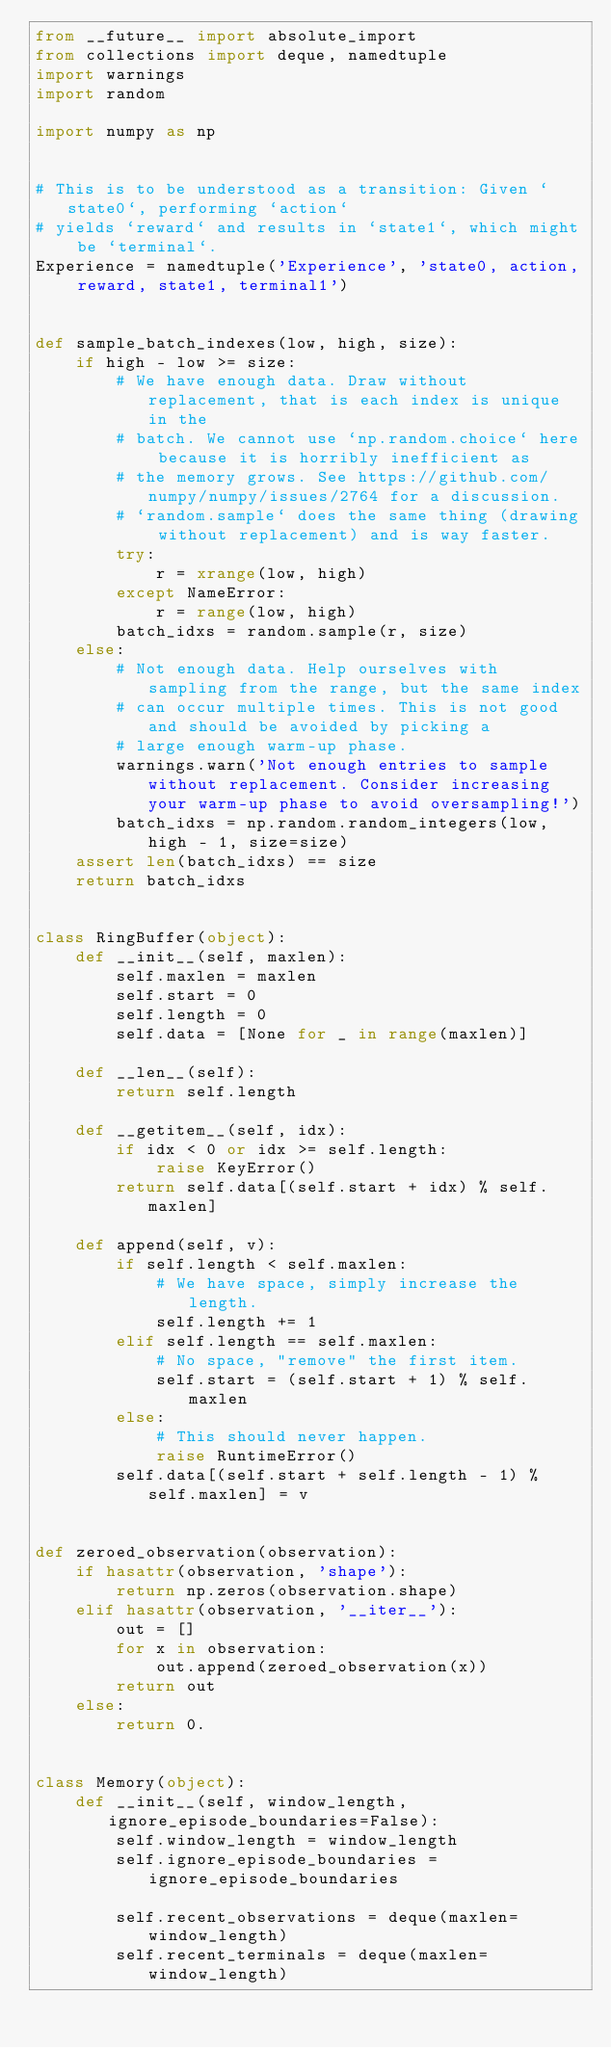<code> <loc_0><loc_0><loc_500><loc_500><_Python_>from __future__ import absolute_import
from collections import deque, namedtuple
import warnings
import random

import numpy as np


# This is to be understood as a transition: Given `state0`, performing `action`
# yields `reward` and results in `state1`, which might be `terminal`.
Experience = namedtuple('Experience', 'state0, action, reward, state1, terminal1')


def sample_batch_indexes(low, high, size):
    if high - low >= size:
        # We have enough data. Draw without replacement, that is each index is unique in the
        # batch. We cannot use `np.random.choice` here because it is horribly inefficient as
        # the memory grows. See https://github.com/numpy/numpy/issues/2764 for a discussion.
        # `random.sample` does the same thing (drawing without replacement) and is way faster.
        try:
            r = xrange(low, high)
        except NameError:
            r = range(low, high)
        batch_idxs = random.sample(r, size)
    else:
        # Not enough data. Help ourselves with sampling from the range, but the same index
        # can occur multiple times. This is not good and should be avoided by picking a
        # large enough warm-up phase.
        warnings.warn('Not enough entries to sample without replacement. Consider increasing your warm-up phase to avoid oversampling!')
        batch_idxs = np.random.random_integers(low, high - 1, size=size)
    assert len(batch_idxs) == size
    return batch_idxs


class RingBuffer(object):
    def __init__(self, maxlen):
        self.maxlen = maxlen
        self.start = 0
        self.length = 0
        self.data = [None for _ in range(maxlen)]

    def __len__(self):
        return self.length

    def __getitem__(self, idx):
        if idx < 0 or idx >= self.length:
            raise KeyError()
        return self.data[(self.start + idx) % self.maxlen]

    def append(self, v):
        if self.length < self.maxlen:
            # We have space, simply increase the length.
            self.length += 1
        elif self.length == self.maxlen:
            # No space, "remove" the first item.
            self.start = (self.start + 1) % self.maxlen
        else:
            # This should never happen.
            raise RuntimeError()
        self.data[(self.start + self.length - 1) % self.maxlen] = v


def zeroed_observation(observation):
    if hasattr(observation, 'shape'):
        return np.zeros(observation.shape)
    elif hasattr(observation, '__iter__'):
        out = []
        for x in observation:
            out.append(zeroed_observation(x))
        return out
    else:
        return 0.


class Memory(object):
    def __init__(self, window_length, ignore_episode_boundaries=False):
        self.window_length = window_length
        self.ignore_episode_boundaries = ignore_episode_boundaries

        self.recent_observations = deque(maxlen=window_length)
        self.recent_terminals = deque(maxlen=window_length)
</code> 